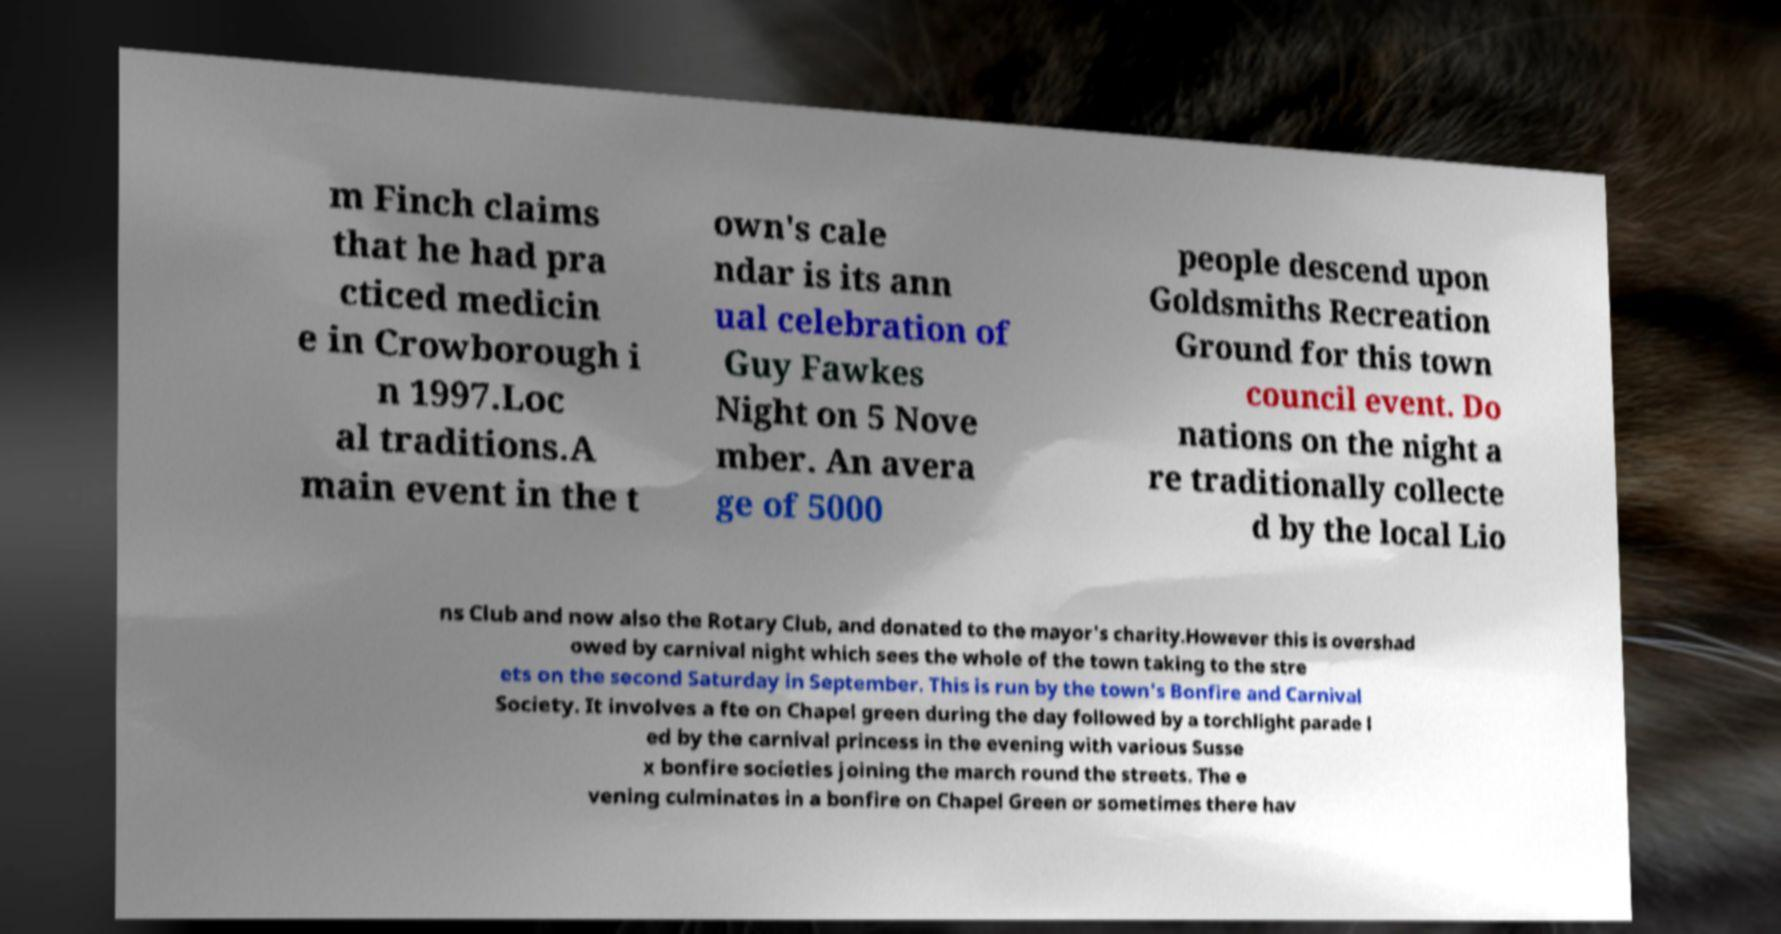Could you extract and type out the text from this image? m Finch claims that he had pra cticed medicin e in Crowborough i n 1997.Loc al traditions.A main event in the t own's cale ndar is its ann ual celebration of Guy Fawkes Night on 5 Nove mber. An avera ge of 5000 people descend upon Goldsmiths Recreation Ground for this town council event. Do nations on the night a re traditionally collecte d by the local Lio ns Club and now also the Rotary Club, and donated to the mayor's charity.However this is overshad owed by carnival night which sees the whole of the town taking to the stre ets on the second Saturday in September. This is run by the town's Bonfire and Carnival Society. It involves a fte on Chapel green during the day followed by a torchlight parade l ed by the carnival princess in the evening with various Susse x bonfire societies joining the march round the streets. The e vening culminates in a bonfire on Chapel Green or sometimes there hav 